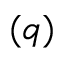Convert formula to latex. <formula><loc_0><loc_0><loc_500><loc_500>( q )</formula> 